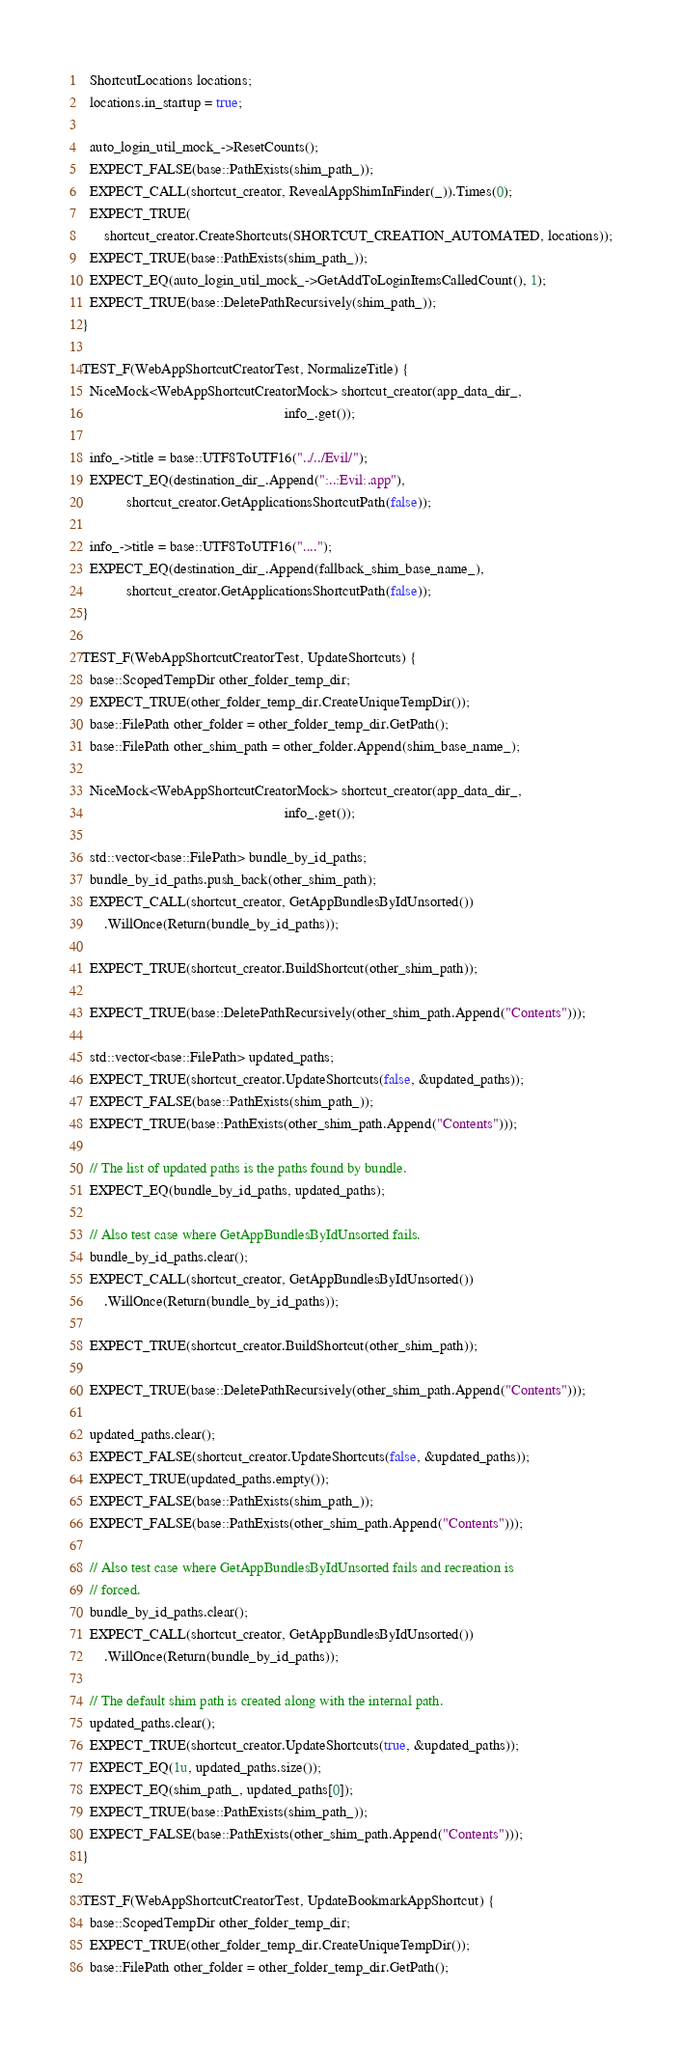<code> <loc_0><loc_0><loc_500><loc_500><_ObjectiveC_>
  ShortcutLocations locations;
  locations.in_startup = true;

  auto_login_util_mock_->ResetCounts();
  EXPECT_FALSE(base::PathExists(shim_path_));
  EXPECT_CALL(shortcut_creator, RevealAppShimInFinder(_)).Times(0);
  EXPECT_TRUE(
      shortcut_creator.CreateShortcuts(SHORTCUT_CREATION_AUTOMATED, locations));
  EXPECT_TRUE(base::PathExists(shim_path_));
  EXPECT_EQ(auto_login_util_mock_->GetAddToLoginItemsCalledCount(), 1);
  EXPECT_TRUE(base::DeletePathRecursively(shim_path_));
}

TEST_F(WebAppShortcutCreatorTest, NormalizeTitle) {
  NiceMock<WebAppShortcutCreatorMock> shortcut_creator(app_data_dir_,
                                                       info_.get());

  info_->title = base::UTF8ToUTF16("../../Evil/");
  EXPECT_EQ(destination_dir_.Append(":..:Evil:.app"),
            shortcut_creator.GetApplicationsShortcutPath(false));

  info_->title = base::UTF8ToUTF16("....");
  EXPECT_EQ(destination_dir_.Append(fallback_shim_base_name_),
            shortcut_creator.GetApplicationsShortcutPath(false));
}

TEST_F(WebAppShortcutCreatorTest, UpdateShortcuts) {
  base::ScopedTempDir other_folder_temp_dir;
  EXPECT_TRUE(other_folder_temp_dir.CreateUniqueTempDir());
  base::FilePath other_folder = other_folder_temp_dir.GetPath();
  base::FilePath other_shim_path = other_folder.Append(shim_base_name_);

  NiceMock<WebAppShortcutCreatorMock> shortcut_creator(app_data_dir_,
                                                       info_.get());

  std::vector<base::FilePath> bundle_by_id_paths;
  bundle_by_id_paths.push_back(other_shim_path);
  EXPECT_CALL(shortcut_creator, GetAppBundlesByIdUnsorted())
      .WillOnce(Return(bundle_by_id_paths));

  EXPECT_TRUE(shortcut_creator.BuildShortcut(other_shim_path));

  EXPECT_TRUE(base::DeletePathRecursively(other_shim_path.Append("Contents")));

  std::vector<base::FilePath> updated_paths;
  EXPECT_TRUE(shortcut_creator.UpdateShortcuts(false, &updated_paths));
  EXPECT_FALSE(base::PathExists(shim_path_));
  EXPECT_TRUE(base::PathExists(other_shim_path.Append("Contents")));

  // The list of updated paths is the paths found by bundle.
  EXPECT_EQ(bundle_by_id_paths, updated_paths);

  // Also test case where GetAppBundlesByIdUnsorted fails.
  bundle_by_id_paths.clear();
  EXPECT_CALL(shortcut_creator, GetAppBundlesByIdUnsorted())
      .WillOnce(Return(bundle_by_id_paths));

  EXPECT_TRUE(shortcut_creator.BuildShortcut(other_shim_path));

  EXPECT_TRUE(base::DeletePathRecursively(other_shim_path.Append("Contents")));

  updated_paths.clear();
  EXPECT_FALSE(shortcut_creator.UpdateShortcuts(false, &updated_paths));
  EXPECT_TRUE(updated_paths.empty());
  EXPECT_FALSE(base::PathExists(shim_path_));
  EXPECT_FALSE(base::PathExists(other_shim_path.Append("Contents")));

  // Also test case where GetAppBundlesByIdUnsorted fails and recreation is
  // forced.
  bundle_by_id_paths.clear();
  EXPECT_CALL(shortcut_creator, GetAppBundlesByIdUnsorted())
      .WillOnce(Return(bundle_by_id_paths));

  // The default shim path is created along with the internal path.
  updated_paths.clear();
  EXPECT_TRUE(shortcut_creator.UpdateShortcuts(true, &updated_paths));
  EXPECT_EQ(1u, updated_paths.size());
  EXPECT_EQ(shim_path_, updated_paths[0]);
  EXPECT_TRUE(base::PathExists(shim_path_));
  EXPECT_FALSE(base::PathExists(other_shim_path.Append("Contents")));
}

TEST_F(WebAppShortcutCreatorTest, UpdateBookmarkAppShortcut) {
  base::ScopedTempDir other_folder_temp_dir;
  EXPECT_TRUE(other_folder_temp_dir.CreateUniqueTempDir());
  base::FilePath other_folder = other_folder_temp_dir.GetPath();</code> 